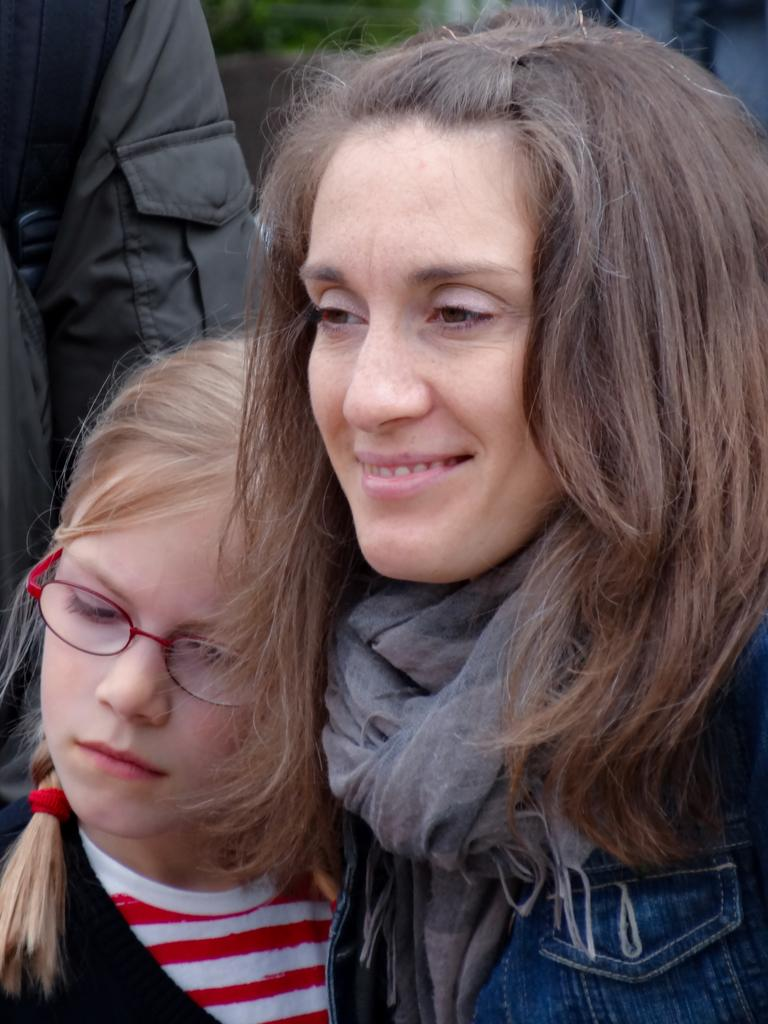How many people are in the image? There are a few people in the image. Can you describe the background of the image? The background of the image is blurred. How many cracks can be seen on the duck's back in the image? There is no duck present in the image, and therefore no cracks on its back can be observed. 